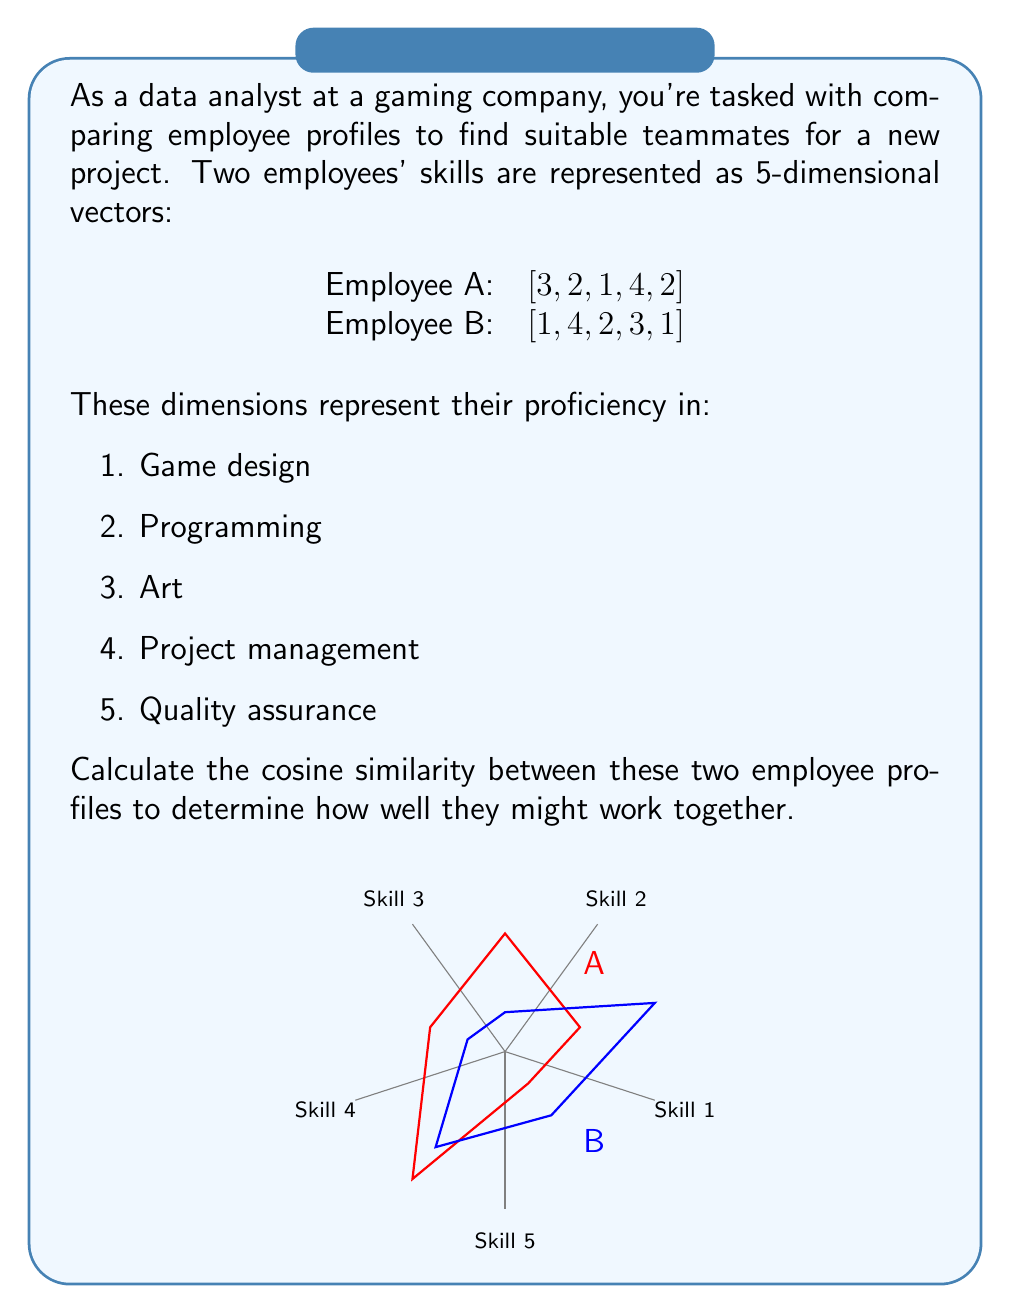Teach me how to tackle this problem. Let's approach this step-by-step:

1) The cosine similarity between two vectors $A$ and $B$ is defined as:

   $$\text{cosine similarity} = \frac{A \cdot B}{\|A\| \|B\|}$$

   Where $A \cdot B$ is the dot product, and $\|A\|$ and $\|B\|$ are the magnitudes of vectors $A$ and $B$ respectively.

2) First, let's calculate the dot product $A \cdot B$:
   
   $A \cdot B = (3 \times 1) + (2 \times 4) + (1 \times 2) + (4 \times 3) + (2 \times 1)$
   $= 3 + 8 + 2 + 12 + 2 = 27$

3) Now, let's calculate the magnitudes:

   $\|A\| = \sqrt{3^2 + 2^2 + 1^2 + 4^2 + 2^2} = \sqrt{9 + 4 + 1 + 16 + 4} = \sqrt{34}$
   
   $\|B\| = \sqrt{1^2 + 4^2 + 2^2 + 3^2 + 1^2} = \sqrt{1 + 16 + 4 + 9 + 1} = \sqrt{31}$

4) Now we can plug these values into our cosine similarity formula:

   $$\text{cosine similarity} = \frac{27}{\sqrt{34} \times \sqrt{31}}$$

5) Simplifying:

   $$\text{cosine similarity} = \frac{27}{\sqrt{1054}} \approx 0.8313$$

This value ranges from -1 to 1, where 1 indicates perfect similarity, 0 indicates no correlation, and -1 indicates perfect dissimilarity. A value of about 0.8313 suggests these employees have quite similar skill profiles and might work well together.
Answer: $0.8313$ 